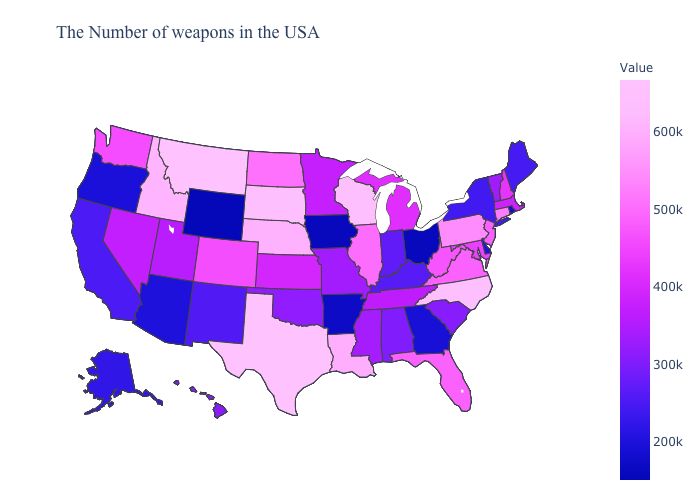Does Nebraska have a lower value than Montana?
Answer briefly. Yes. Among the states that border Illinois , does Wisconsin have the highest value?
Be succinct. Yes. Which states have the lowest value in the MidWest?
Give a very brief answer. Iowa. Does Wyoming have the lowest value in the USA?
Short answer required. Yes. Among the states that border Kentucky , does Missouri have the lowest value?
Concise answer only. No. 